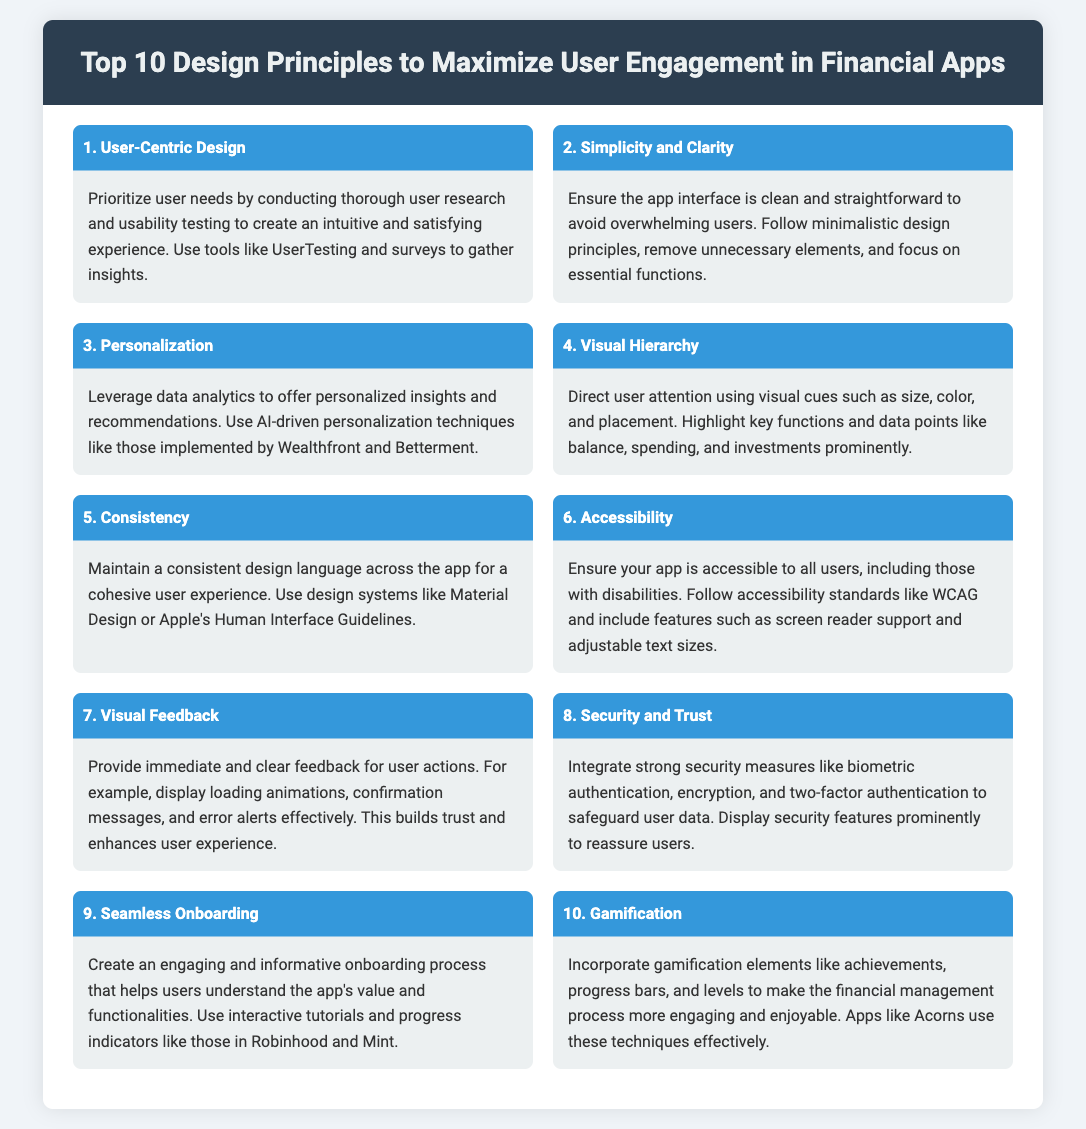What is the first design principle? The first design principle listed in the document is User-Centric Design, which emphasizes prioritizing user needs through research and testing.
Answer: User-Centric Design What principle involves the use of data analytics? The design principle that involves the use of data analytics for personalized insights is Personalization.
Answer: Personalization How many design principles are listed in total? The document enumerates a total of ten design principles for financial apps.
Answer: 10 What design principle focuses on maintaining a consistent design language? The design principle that focuses on maintaining a consistent design language across the app is Consistency.
Answer: Consistency Which design principle emphasizes immediate feedback for user actions? The principle that emphasizes providing immediate and clear feedback for user actions is Visual Feedback.
Answer: Visual Feedback What is suggested for ensuring accessibility in the app? The document suggests following accessibility standards like WCAG and including features such as screen reader support for ensuring accessibility.
Answer: WCAG What design principle incorporates achievements and progress bars? The design principle that incorporates elements like achievements and progress bars is Gamification.
Answer: Gamification Which financial apps are mentioned as examples for onboarding processes? The examples of financial apps that have engaging onboarding processes are Robinhood and Mint.
Answer: Robinhood and Mint What color scheme is used in the container header? The color scheme used in the container header features a background color of #2c3e50 and text color of #ecf0f1.
Answer: #2c3e50 and #ecf0f1 